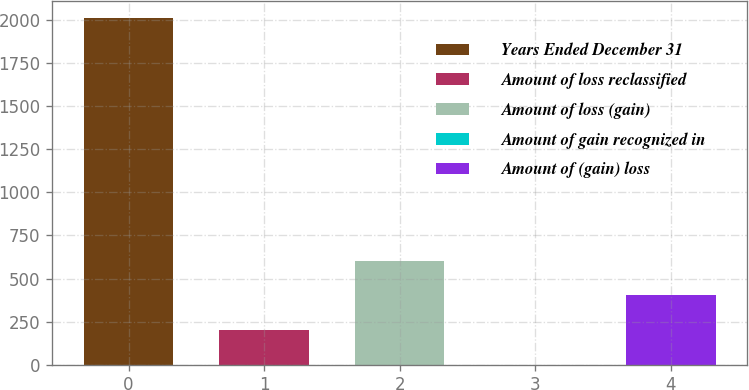Convert chart to OTSL. <chart><loc_0><loc_0><loc_500><loc_500><bar_chart><fcel>Years Ended December 31<fcel>Amount of loss reclassified<fcel>Amount of loss (gain)<fcel>Amount of gain recognized in<fcel>Amount of (gain) loss<nl><fcel>2010<fcel>201.9<fcel>603.7<fcel>1<fcel>402.8<nl></chart> 